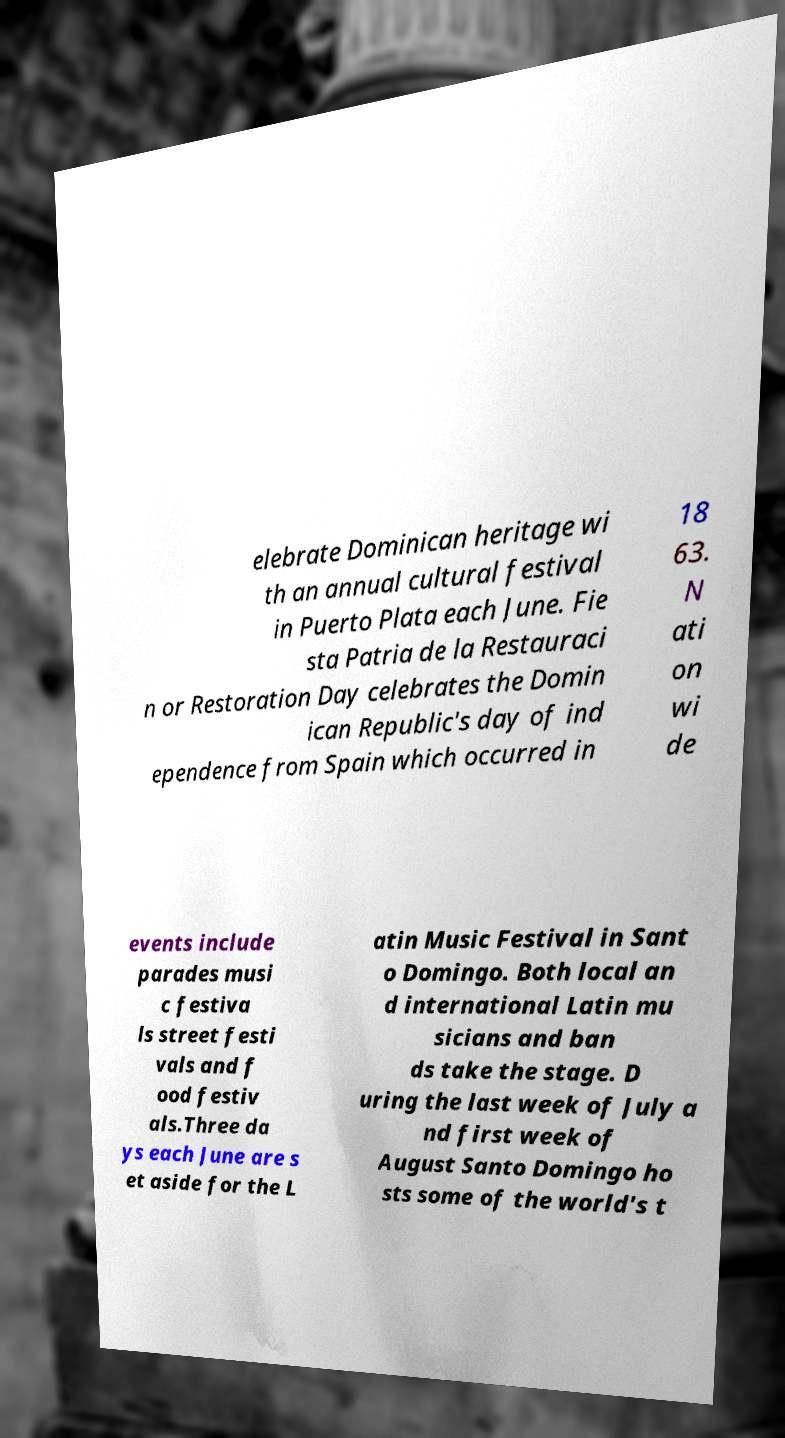Can you read and provide the text displayed in the image?This photo seems to have some interesting text. Can you extract and type it out for me? elebrate Dominican heritage wi th an annual cultural festival in Puerto Plata each June. Fie sta Patria de la Restauraci n or Restoration Day celebrates the Domin ican Republic's day of ind ependence from Spain which occurred in 18 63. N ati on wi de events include parades musi c festiva ls street festi vals and f ood festiv als.Three da ys each June are s et aside for the L atin Music Festival in Sant o Domingo. Both local an d international Latin mu sicians and ban ds take the stage. D uring the last week of July a nd first week of August Santo Domingo ho sts some of the world's t 